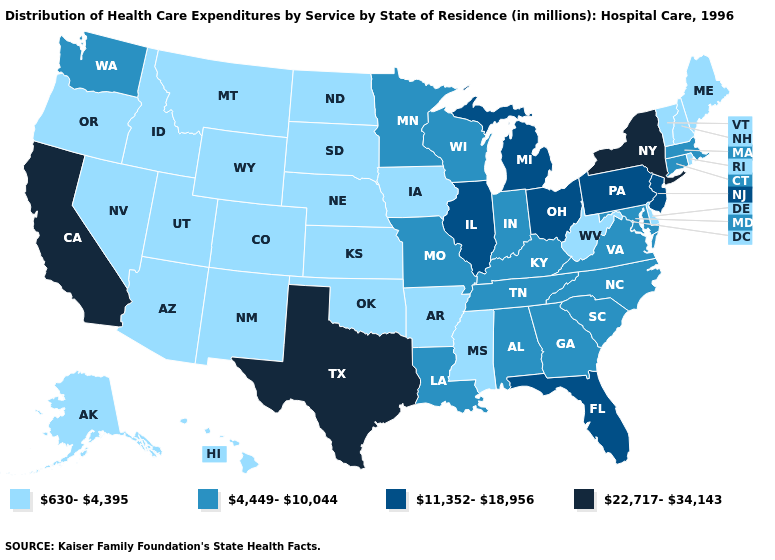Name the states that have a value in the range 4,449-10,044?
Be succinct. Alabama, Connecticut, Georgia, Indiana, Kentucky, Louisiana, Maryland, Massachusetts, Minnesota, Missouri, North Carolina, South Carolina, Tennessee, Virginia, Washington, Wisconsin. What is the highest value in the USA?
Keep it brief. 22,717-34,143. Which states have the lowest value in the West?
Short answer required. Alaska, Arizona, Colorado, Hawaii, Idaho, Montana, Nevada, New Mexico, Oregon, Utah, Wyoming. Which states hav the highest value in the MidWest?
Be succinct. Illinois, Michigan, Ohio. Which states have the lowest value in the West?
Give a very brief answer. Alaska, Arizona, Colorado, Hawaii, Idaho, Montana, Nevada, New Mexico, Oregon, Utah, Wyoming. What is the value of Hawaii?
Keep it brief. 630-4,395. Does Colorado have the highest value in the West?
Be succinct. No. Among the states that border Mississippi , does Tennessee have the highest value?
Quick response, please. Yes. Does the map have missing data?
Quick response, please. No. What is the value of Oregon?
Quick response, please. 630-4,395. How many symbols are there in the legend?
Concise answer only. 4. What is the value of New Hampshire?
Write a very short answer. 630-4,395. Name the states that have a value in the range 11,352-18,956?
Quick response, please. Florida, Illinois, Michigan, New Jersey, Ohio, Pennsylvania. Name the states that have a value in the range 22,717-34,143?
Quick response, please. California, New York, Texas. 